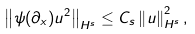Convert formula to latex. <formula><loc_0><loc_0><loc_500><loc_500>\left \| \psi ( \partial _ { x } ) u ^ { 2 } \right \| _ { H ^ { s } } \leq C _ { s } \left \| u \right \| ^ { 2 } _ { H ^ { s } } ,</formula> 